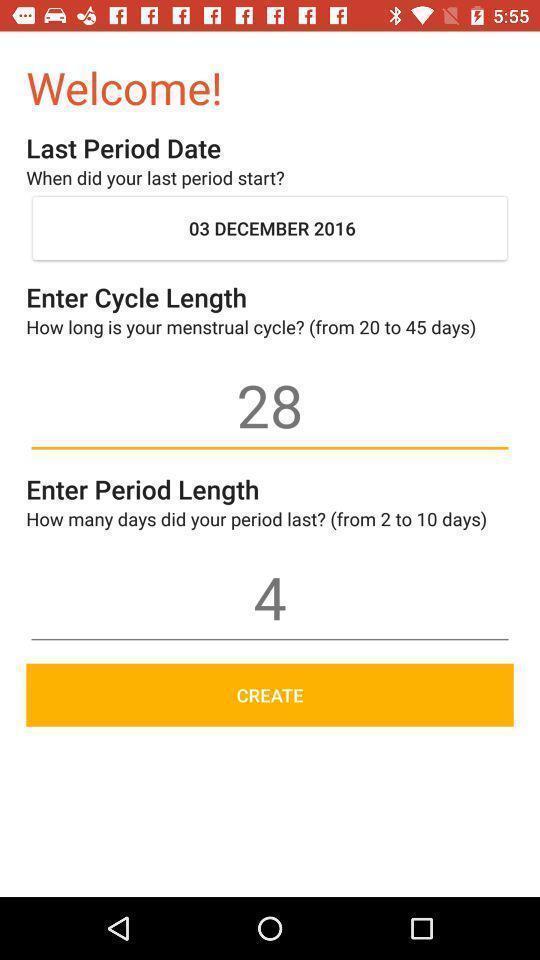Give me a summary of this screen capture. Welcome page with details in a period tracking app. 